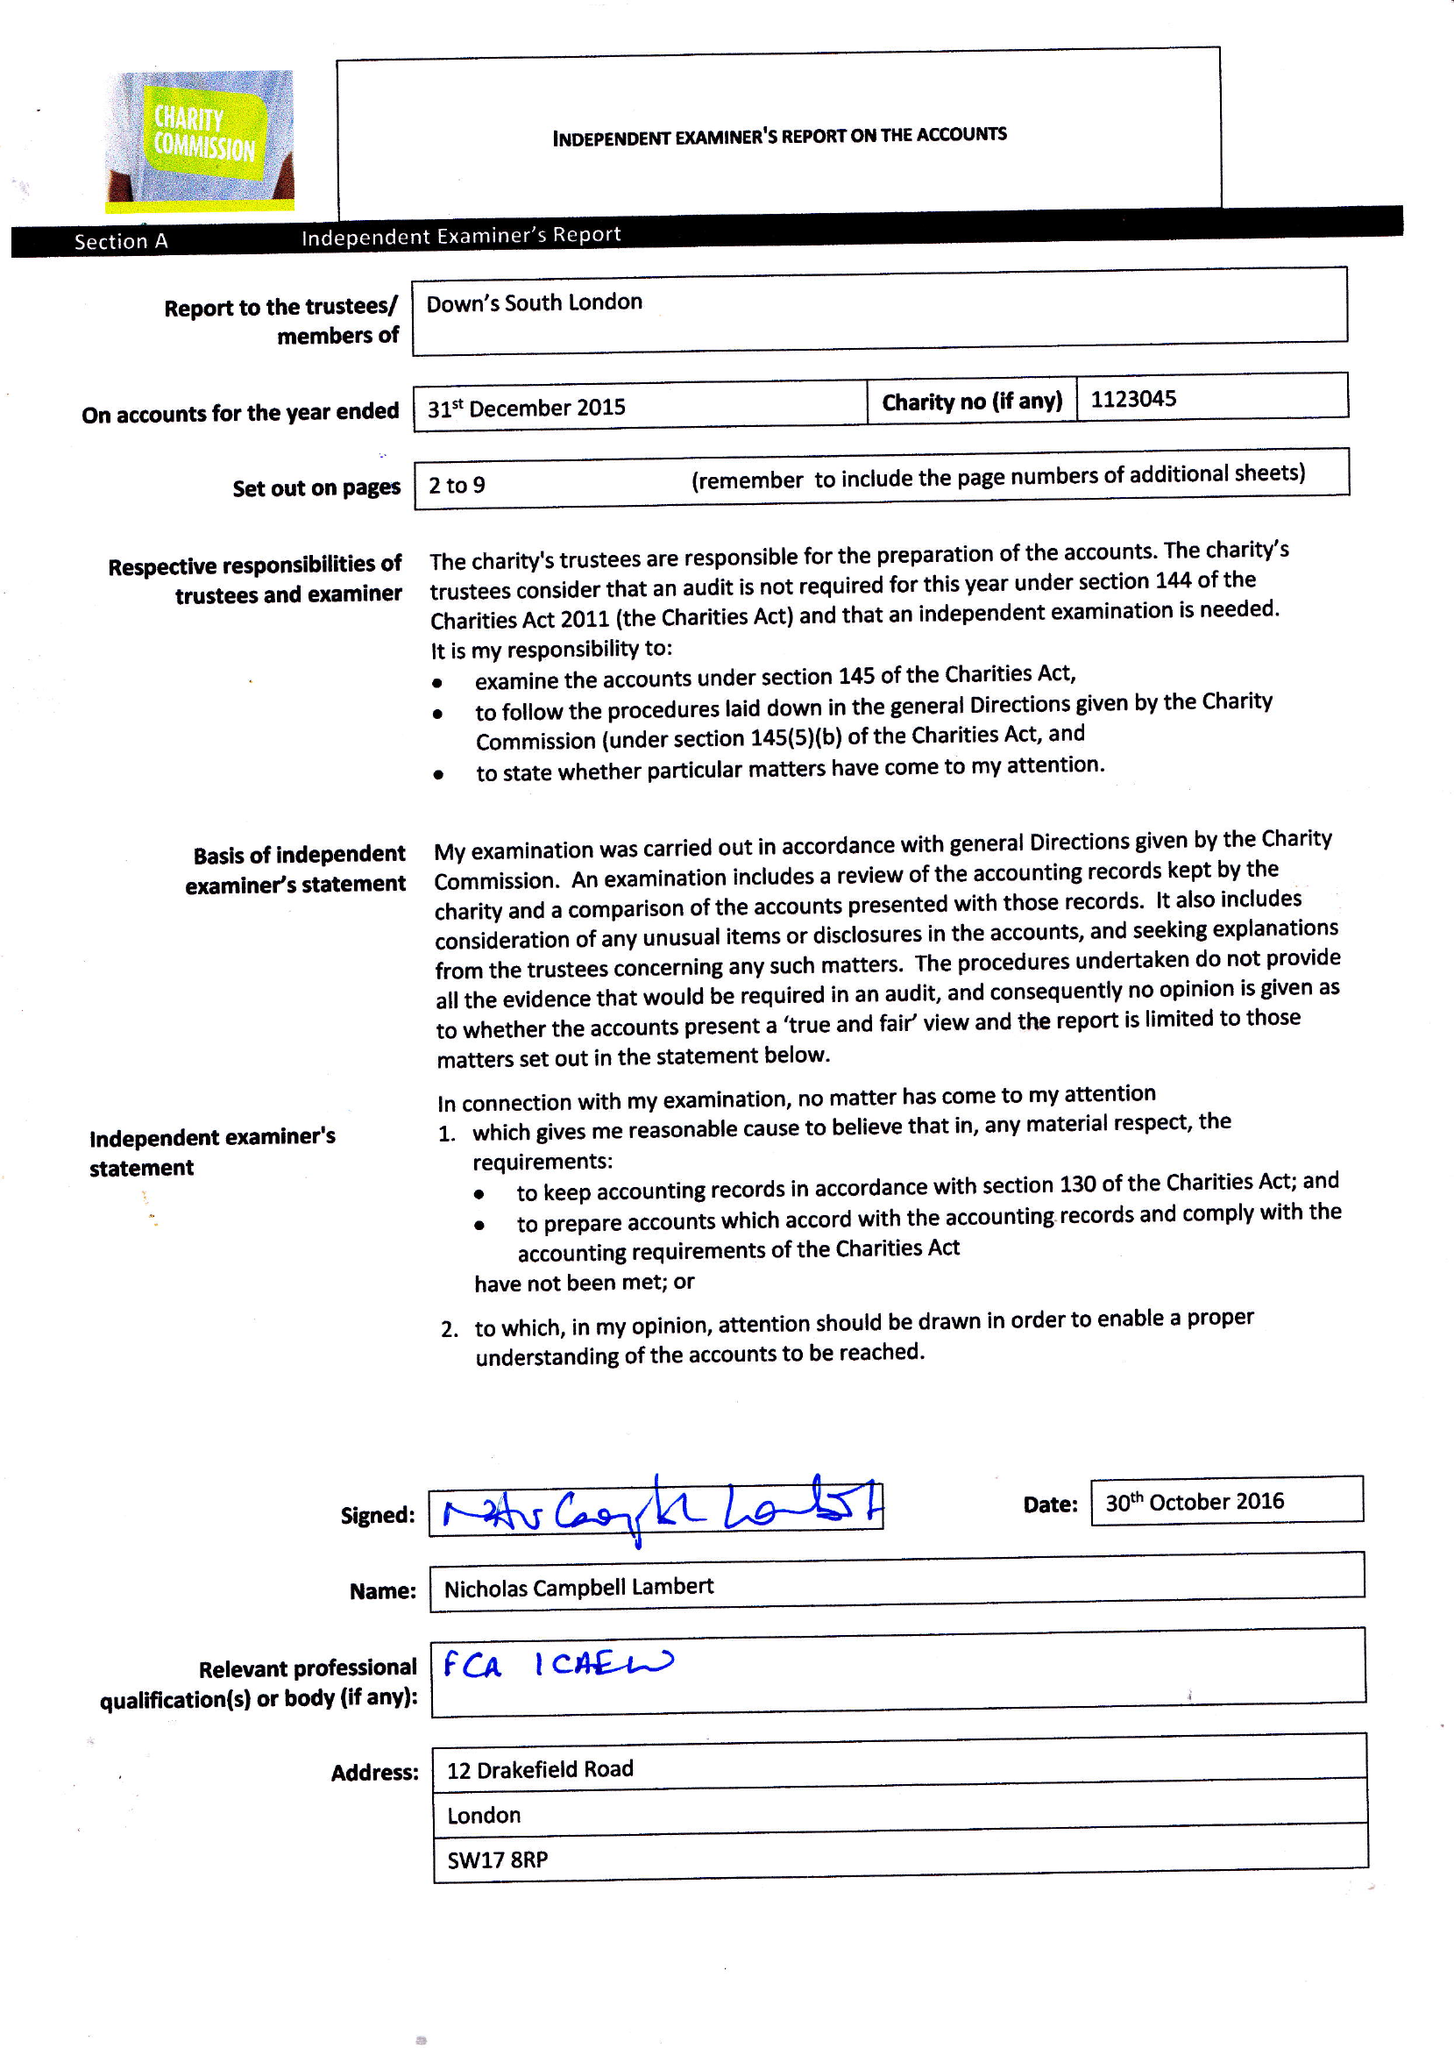What is the value for the report_date?
Answer the question using a single word or phrase. 2015-12-31 